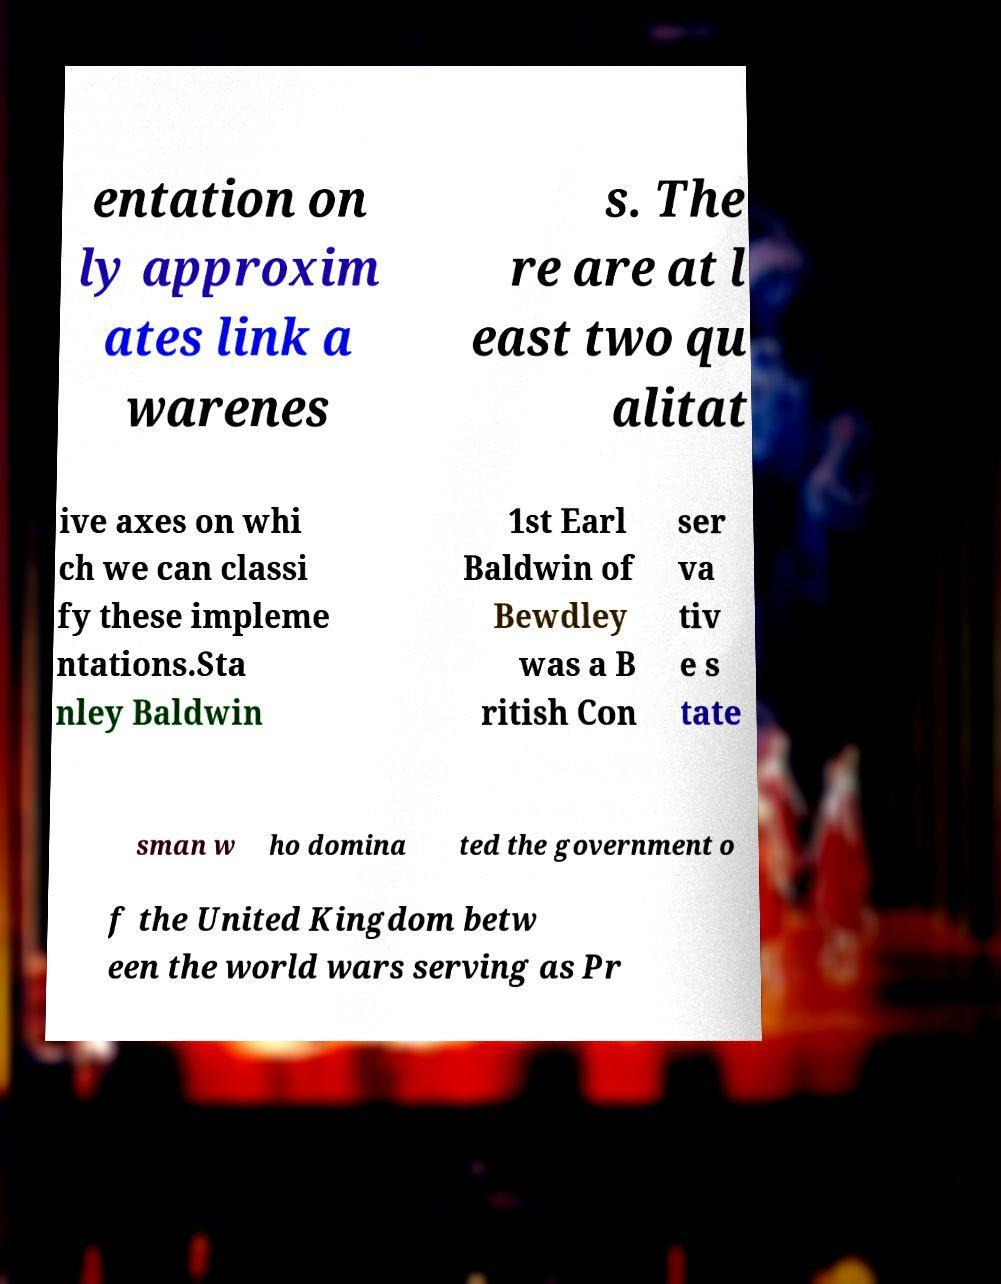For documentation purposes, I need the text within this image transcribed. Could you provide that? entation on ly approxim ates link a warenes s. The re are at l east two qu alitat ive axes on whi ch we can classi fy these impleme ntations.Sta nley Baldwin 1st Earl Baldwin of Bewdley was a B ritish Con ser va tiv e s tate sman w ho domina ted the government o f the United Kingdom betw een the world wars serving as Pr 